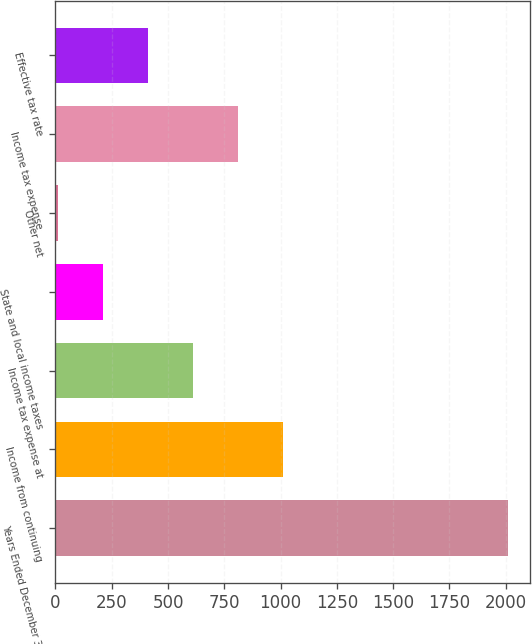Convert chart to OTSL. <chart><loc_0><loc_0><loc_500><loc_500><bar_chart><fcel>Years Ended December 31<fcel>Income from continuing<fcel>Income tax expense at<fcel>State and local income taxes<fcel>Other net<fcel>Income tax expense<fcel>Effective tax rate<nl><fcel>2010<fcel>1010<fcel>610<fcel>210<fcel>10<fcel>810<fcel>410<nl></chart> 